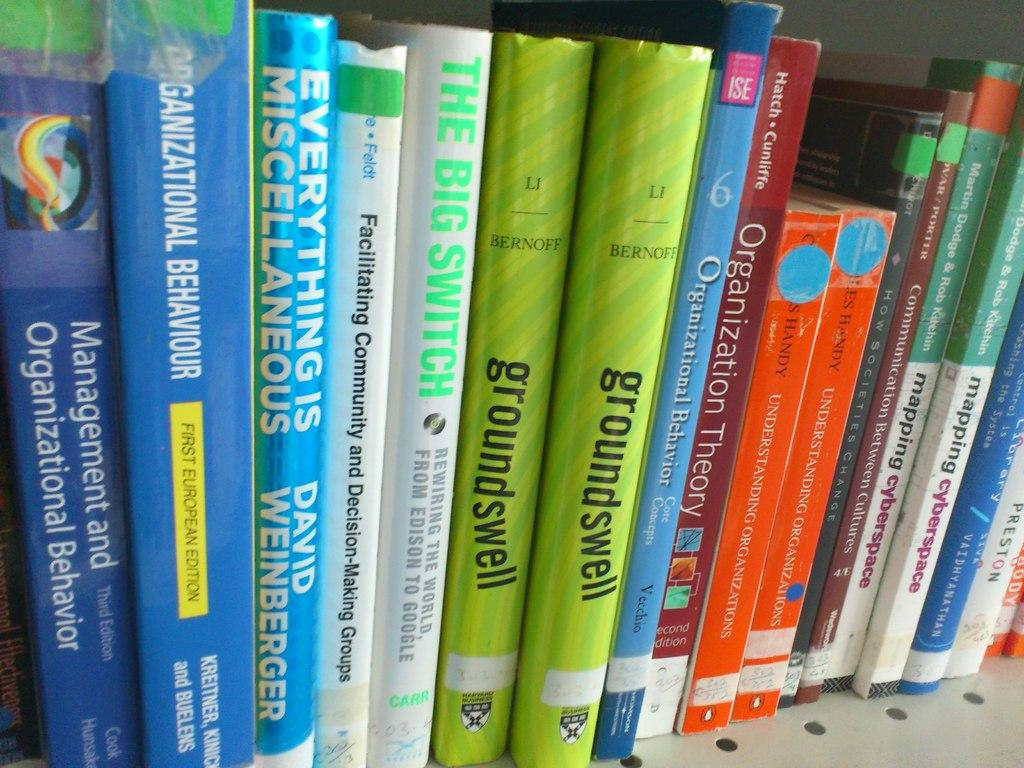Provide a one-sentence caption for the provided image. a shelf of books, one of them says groundswell. 